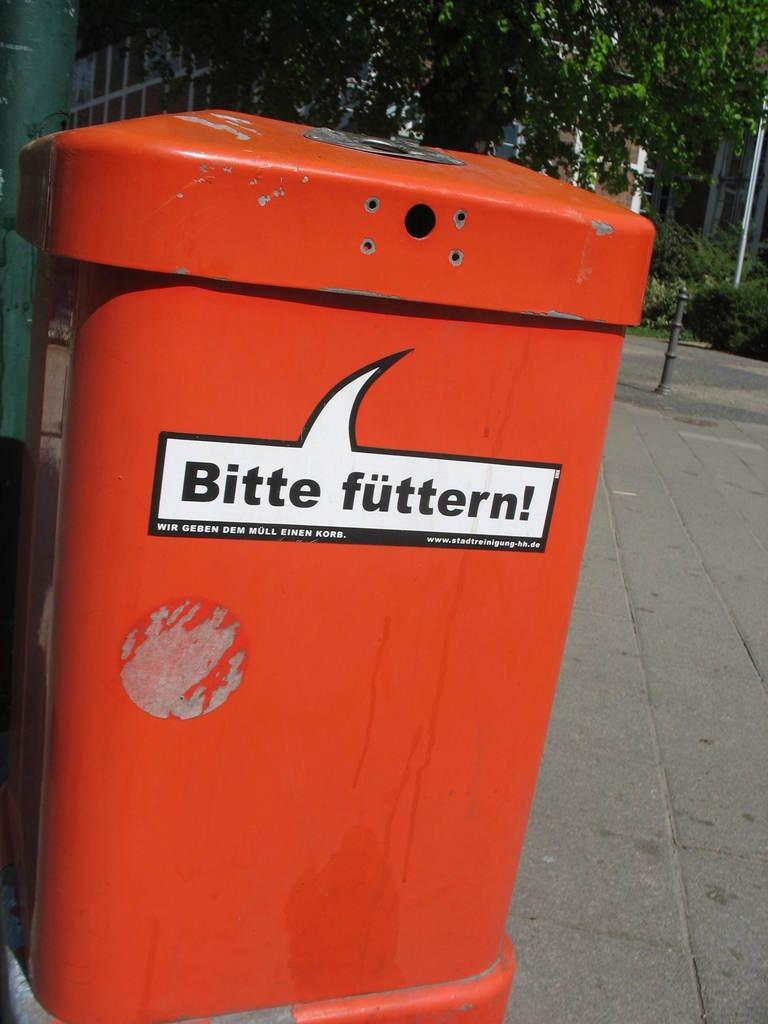Provide a one-sentence caption for the provided image. An orange container on the street reads Bitte futtern!. 